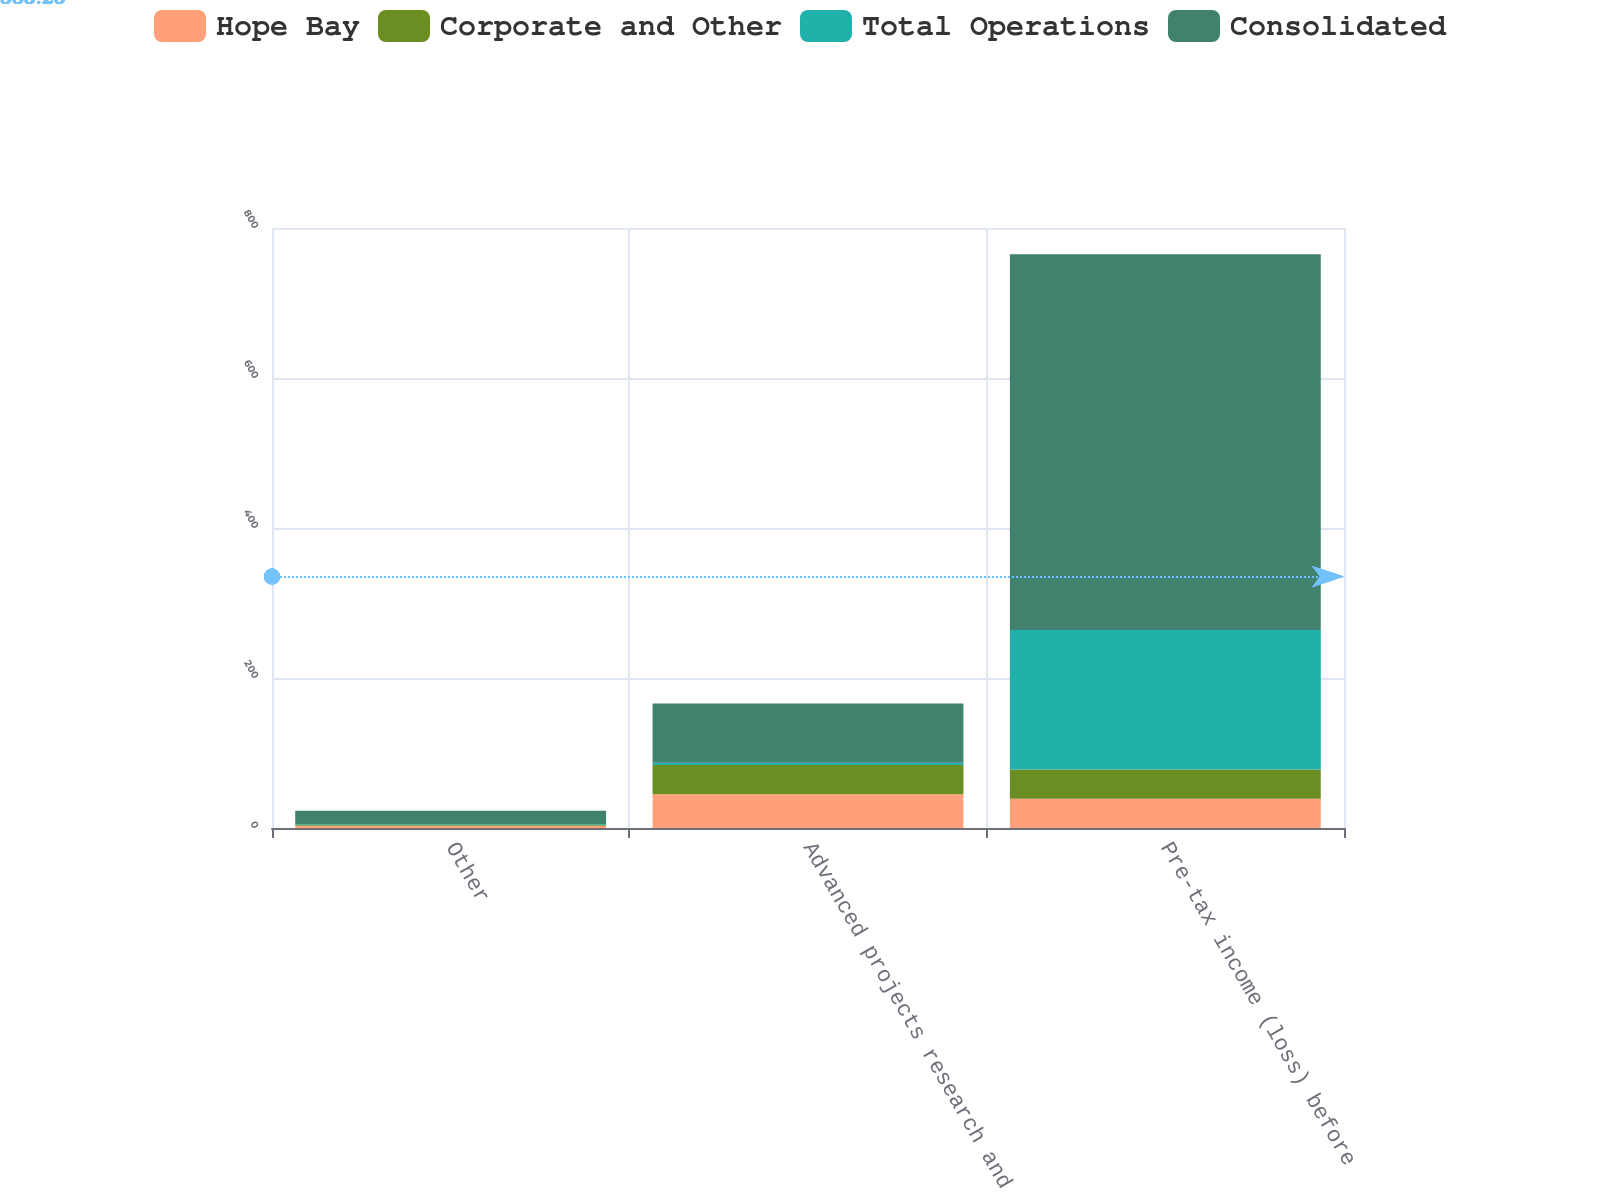Convert chart to OTSL. <chart><loc_0><loc_0><loc_500><loc_500><stacked_bar_chart><ecel><fcel>Other<fcel>Advanced projects research and<fcel>Pre-tax income (loss) before<nl><fcel>Hope Bay<fcel>3<fcel>45<fcel>39<nl><fcel>Corporate and Other<fcel>1<fcel>39<fcel>39<nl><fcel>Total Operations<fcel>1<fcel>3<fcel>186<nl><fcel>Consolidated<fcel>18<fcel>79<fcel>501<nl></chart> 